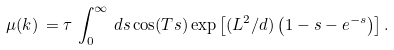Convert formula to latex. <formula><loc_0><loc_0><loc_500><loc_500>\mu ( k ) \, = \tau \, \int _ { 0 } ^ { \infty } \, d s \cos ( T s ) \exp \left [ ( L ^ { 2 } / d ) \left ( 1 - s - e ^ { - s } \right ) \right ] .</formula> 